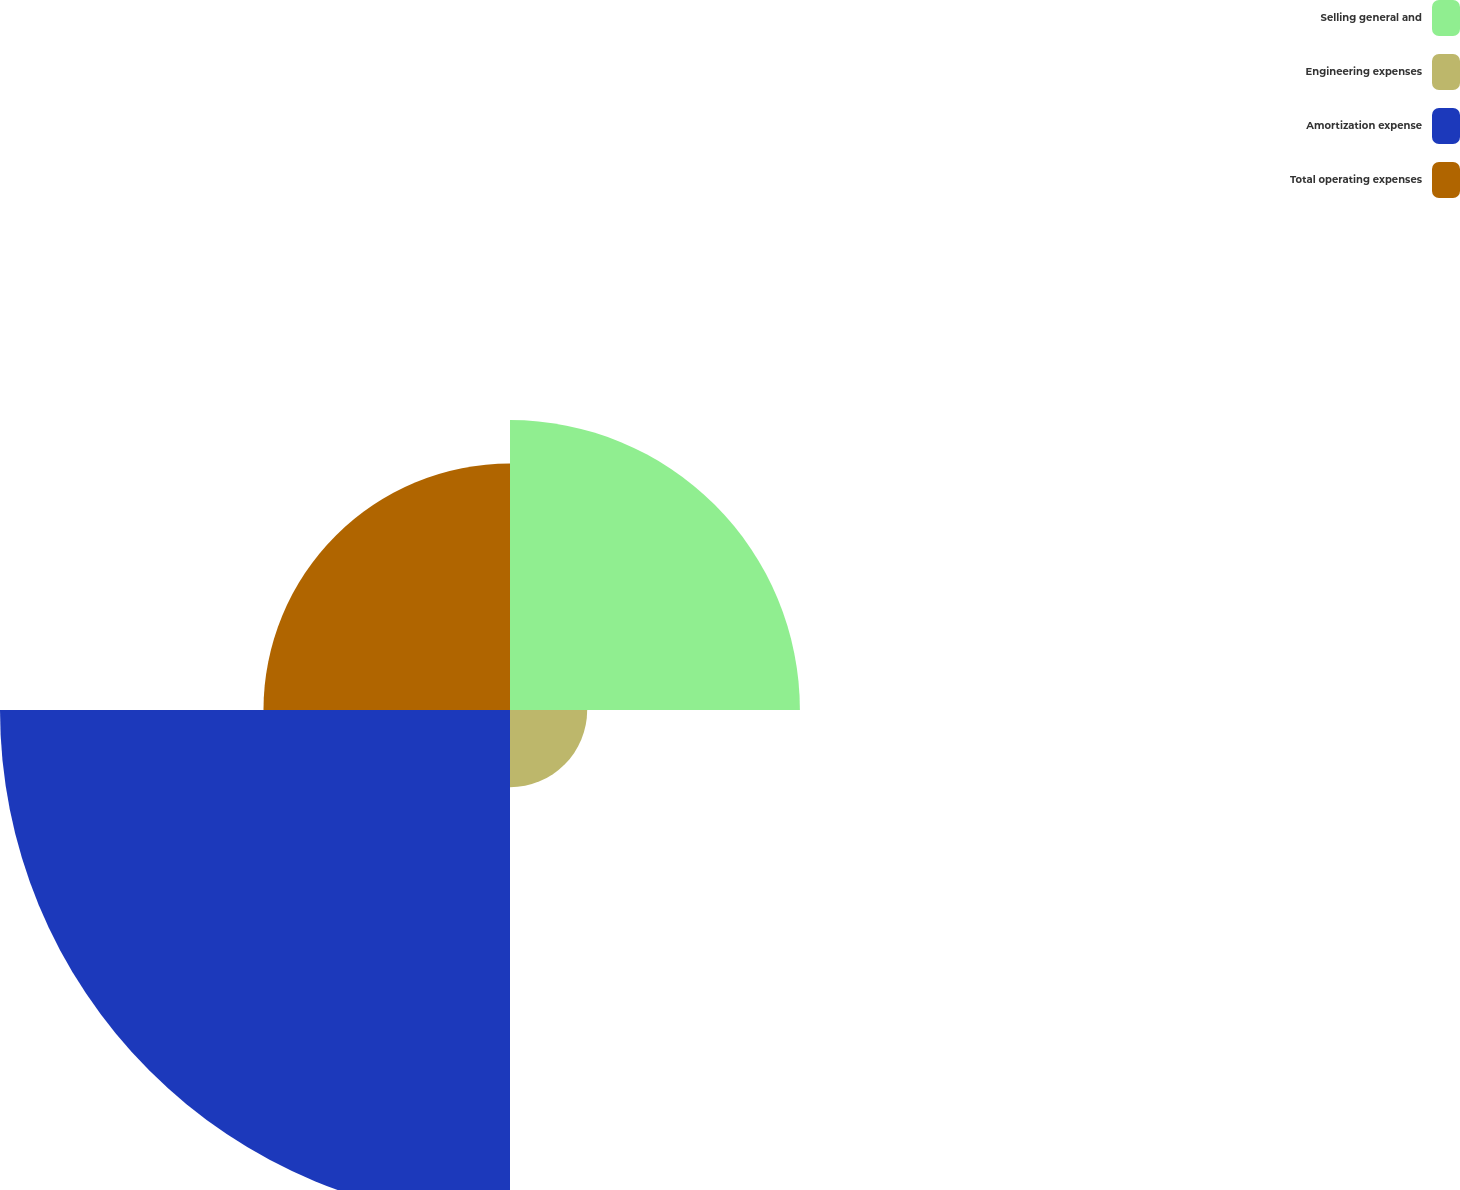Convert chart. <chart><loc_0><loc_0><loc_500><loc_500><pie_chart><fcel>Selling general and<fcel>Engineering expenses<fcel>Amortization expense<fcel>Total operating expenses<nl><fcel>25.8%<fcel>6.87%<fcel>45.39%<fcel>21.94%<nl></chart> 